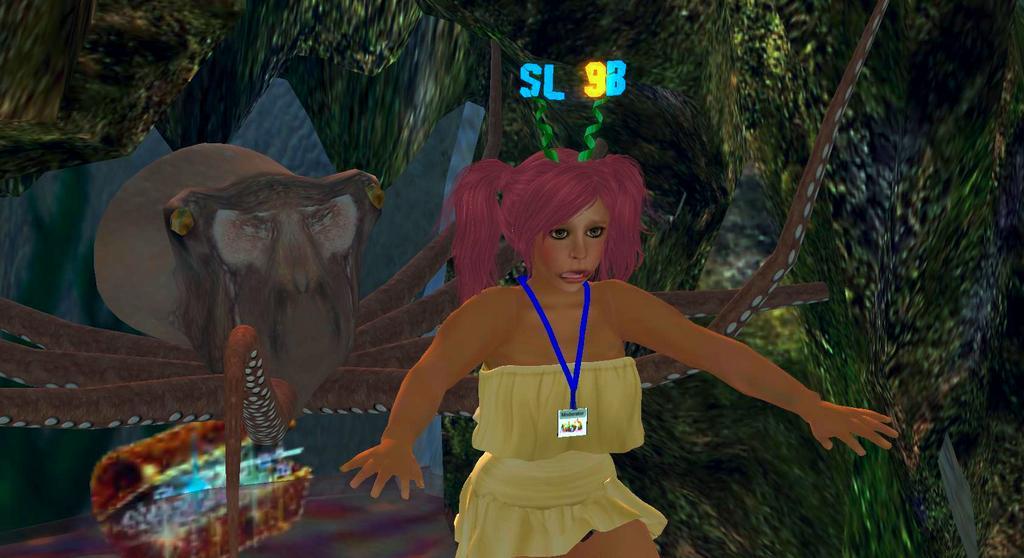In one or two sentences, can you explain what this image depicts? This is an edited and animated image in which in the front there is a woman and in the back ground there are objects which are green, brown and blue in colour and there is some text and number written in the background. 